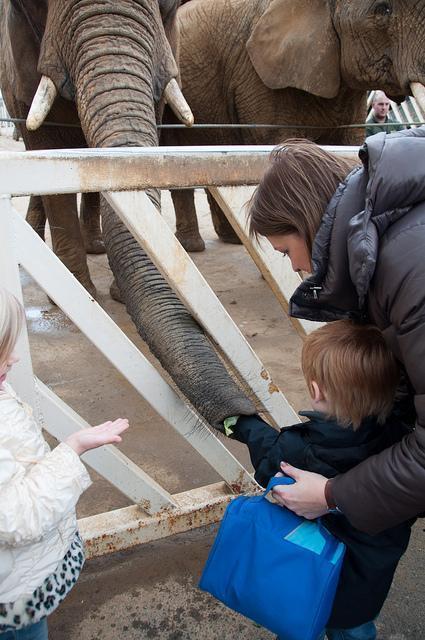Where are the elephants behind held?
Pick the correct solution from the four options below to address the question.
Options: In circus, in park, in zoo, in prison. In zoo. 